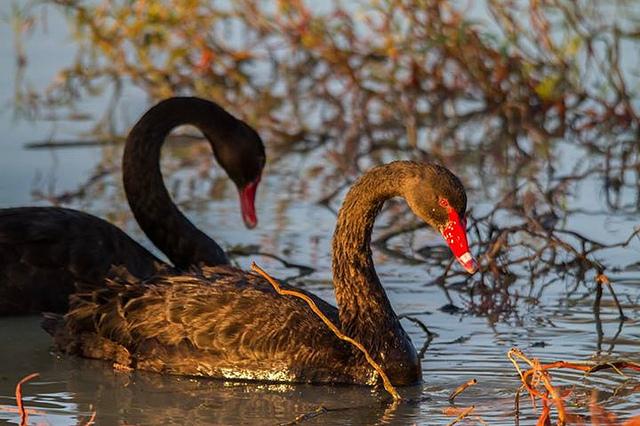What type of animal are these?
Keep it brief. Swans. What are these birds doing?
Short answer required. Swimming. Are both birds the same type of bird?
Give a very brief answer. Yes. 